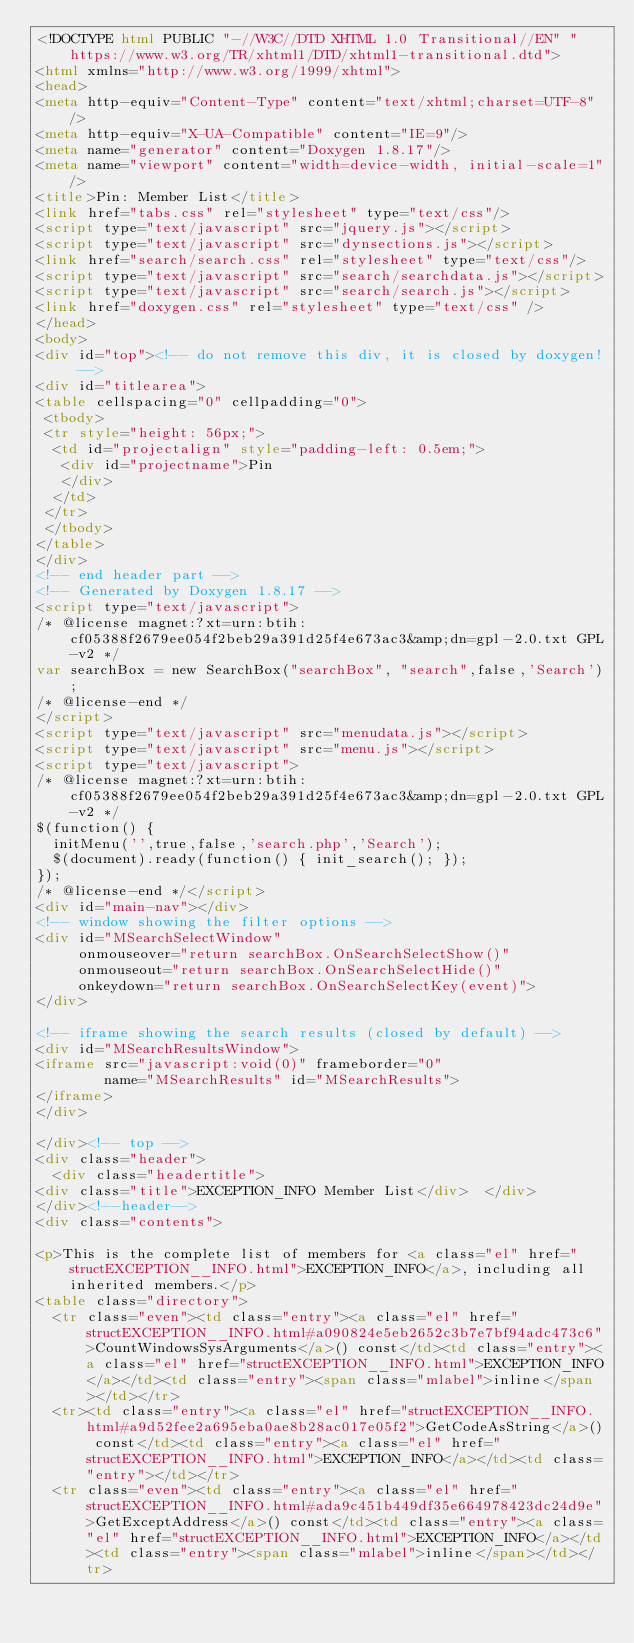<code> <loc_0><loc_0><loc_500><loc_500><_HTML_><!DOCTYPE html PUBLIC "-//W3C//DTD XHTML 1.0 Transitional//EN" "https://www.w3.org/TR/xhtml1/DTD/xhtml1-transitional.dtd">
<html xmlns="http://www.w3.org/1999/xhtml">
<head>
<meta http-equiv="Content-Type" content="text/xhtml;charset=UTF-8"/>
<meta http-equiv="X-UA-Compatible" content="IE=9"/>
<meta name="generator" content="Doxygen 1.8.17"/>
<meta name="viewport" content="width=device-width, initial-scale=1"/>
<title>Pin: Member List</title>
<link href="tabs.css" rel="stylesheet" type="text/css"/>
<script type="text/javascript" src="jquery.js"></script>
<script type="text/javascript" src="dynsections.js"></script>
<link href="search/search.css" rel="stylesheet" type="text/css"/>
<script type="text/javascript" src="search/searchdata.js"></script>
<script type="text/javascript" src="search/search.js"></script>
<link href="doxygen.css" rel="stylesheet" type="text/css" />
</head>
<body>
<div id="top"><!-- do not remove this div, it is closed by doxygen! -->
<div id="titlearea">
<table cellspacing="0" cellpadding="0">
 <tbody>
 <tr style="height: 56px;">
  <td id="projectalign" style="padding-left: 0.5em;">
   <div id="projectname">Pin
   </div>
  </td>
 </tr>
 </tbody>
</table>
</div>
<!-- end header part -->
<!-- Generated by Doxygen 1.8.17 -->
<script type="text/javascript">
/* @license magnet:?xt=urn:btih:cf05388f2679ee054f2beb29a391d25f4e673ac3&amp;dn=gpl-2.0.txt GPL-v2 */
var searchBox = new SearchBox("searchBox", "search",false,'Search');
/* @license-end */
</script>
<script type="text/javascript" src="menudata.js"></script>
<script type="text/javascript" src="menu.js"></script>
<script type="text/javascript">
/* @license magnet:?xt=urn:btih:cf05388f2679ee054f2beb29a391d25f4e673ac3&amp;dn=gpl-2.0.txt GPL-v2 */
$(function() {
  initMenu('',true,false,'search.php','Search');
  $(document).ready(function() { init_search(); });
});
/* @license-end */</script>
<div id="main-nav"></div>
<!-- window showing the filter options -->
<div id="MSearchSelectWindow"
     onmouseover="return searchBox.OnSearchSelectShow()"
     onmouseout="return searchBox.OnSearchSelectHide()"
     onkeydown="return searchBox.OnSearchSelectKey(event)">
</div>

<!-- iframe showing the search results (closed by default) -->
<div id="MSearchResultsWindow">
<iframe src="javascript:void(0)" frameborder="0" 
        name="MSearchResults" id="MSearchResults">
</iframe>
</div>

</div><!-- top -->
<div class="header">
  <div class="headertitle">
<div class="title">EXCEPTION_INFO Member List</div>  </div>
</div><!--header-->
<div class="contents">

<p>This is the complete list of members for <a class="el" href="structEXCEPTION__INFO.html">EXCEPTION_INFO</a>, including all inherited members.</p>
<table class="directory">
  <tr class="even"><td class="entry"><a class="el" href="structEXCEPTION__INFO.html#a090824e5eb2652c3b7e7bf94adc473c6">CountWindowsSysArguments</a>() const</td><td class="entry"><a class="el" href="structEXCEPTION__INFO.html">EXCEPTION_INFO</a></td><td class="entry"><span class="mlabel">inline</span></td></tr>
  <tr><td class="entry"><a class="el" href="structEXCEPTION__INFO.html#a9d52fee2a695eba0ae8b28ac017e05f2">GetCodeAsString</a>() const</td><td class="entry"><a class="el" href="structEXCEPTION__INFO.html">EXCEPTION_INFO</a></td><td class="entry"></td></tr>
  <tr class="even"><td class="entry"><a class="el" href="structEXCEPTION__INFO.html#ada9c451b449df35e664978423dc24d9e">GetExceptAddress</a>() const</td><td class="entry"><a class="el" href="structEXCEPTION__INFO.html">EXCEPTION_INFO</a></td><td class="entry"><span class="mlabel">inline</span></td></tr></code> 